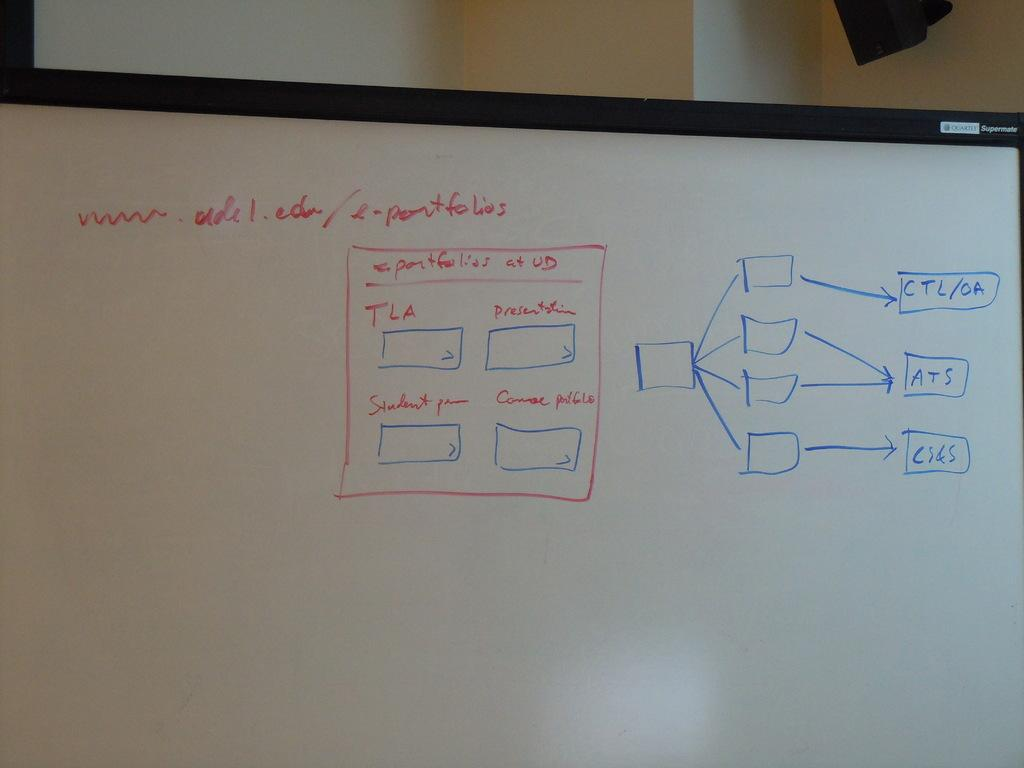Provide a one-sentence caption for the provided image. a white board with e-portfolios written on it. 